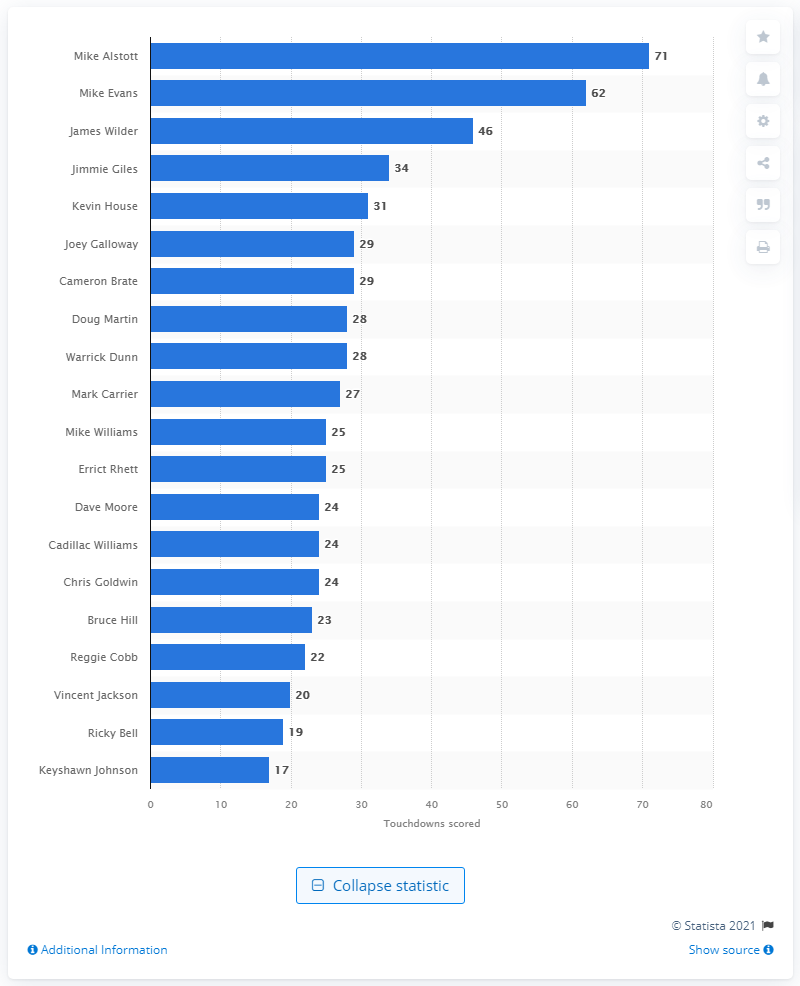List a handful of essential elements in this visual. Mike Alstott is the career touchdown leader of the Tampa Bay Buccaneers. Mike Alstott has scored 71 touchdowns for the Tampa Bay Buccaneers. 